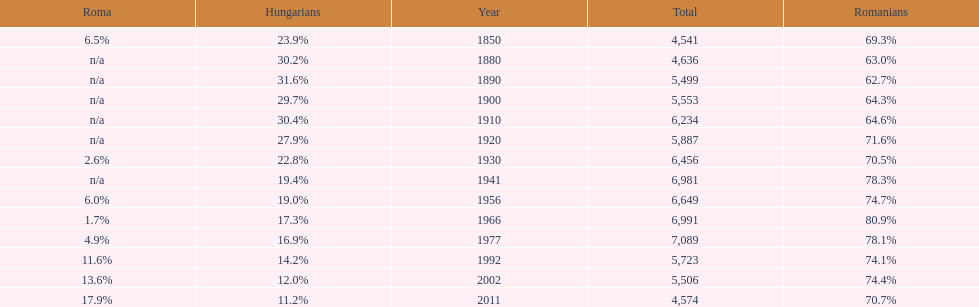What were the total number of times the romanians had a population percentage above 70%? 9. 